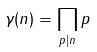Convert formula to latex. <formula><loc_0><loc_0><loc_500><loc_500>\gamma ( n ) = \prod _ { p | n } p</formula> 